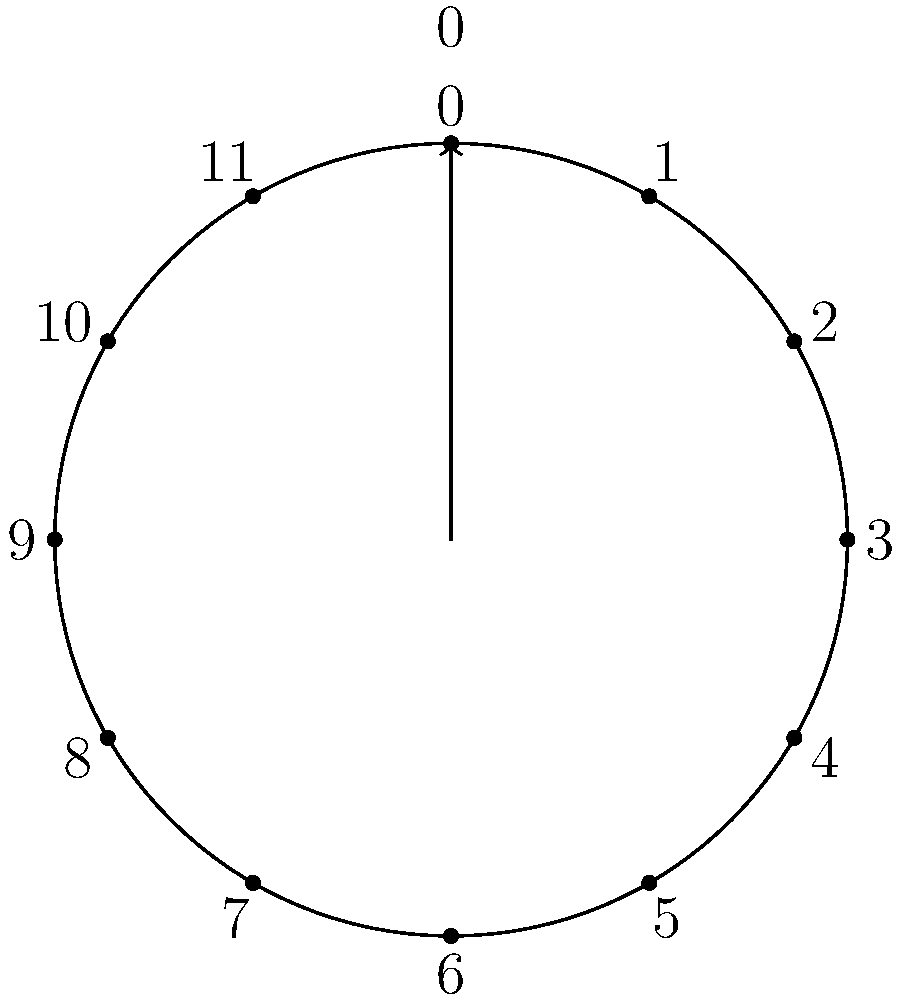As a freelance writer aiming to enhance your understanding of group theory for an upcoming article, consider the cyclic group $C_{12}$ represented by a clock face. If you start at 0 and repeatedly add 5 (mod 12), what is the order of the subgroup generated by this operation? To find the order of the subgroup, we need to follow these steps:

1) Start at 0 and repeatedly add 5 (mod 12):
   0 → 5 → 10 → 3 → 8 → 1 → 6 → 11 → 4 → 9 → 2 → 7 → 0

2) Count the number of unique elements before returning to 0:
   We get 12 unique elements before returning to 0.

3) This means that the operation of adding 5 (mod 12) generates all elements of $C_{12}$.

4) In group theory terms, 5 and 12 are coprime, so adding 5 generates the entire group.

5) The order of a group is the number of elements in the group.

Therefore, the order of the subgroup generated by this operation is 12, which is the same as the order of the entire group $C_{12}$.
Answer: 12 